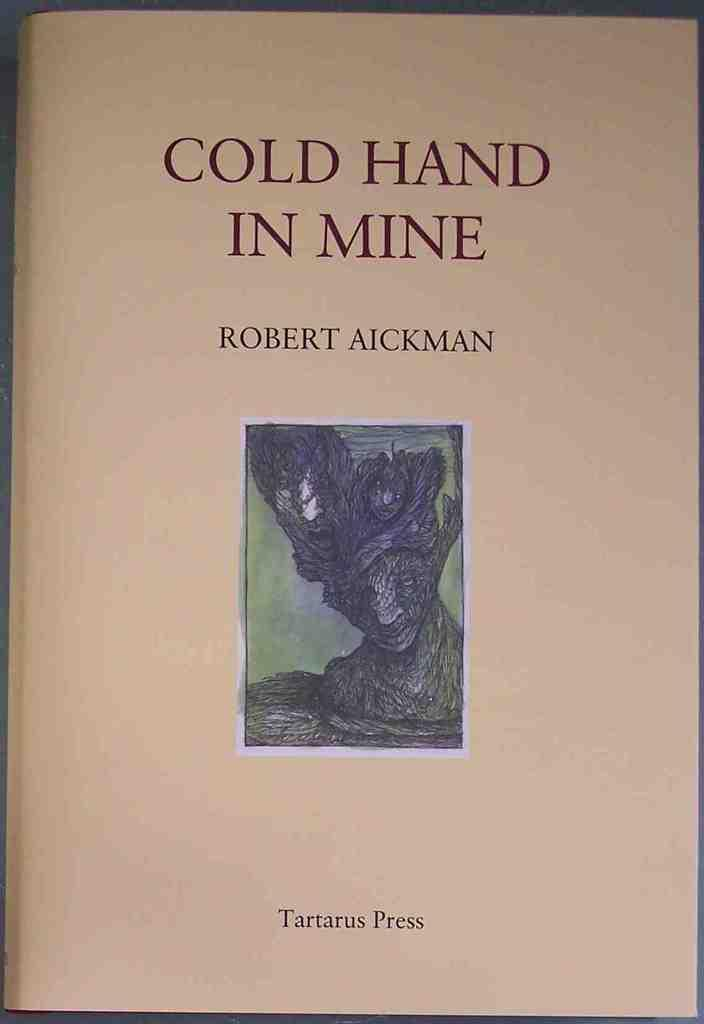<image>
Summarize the visual content of the image. a book that says 'cold hand in mine' by robert aickman on it 